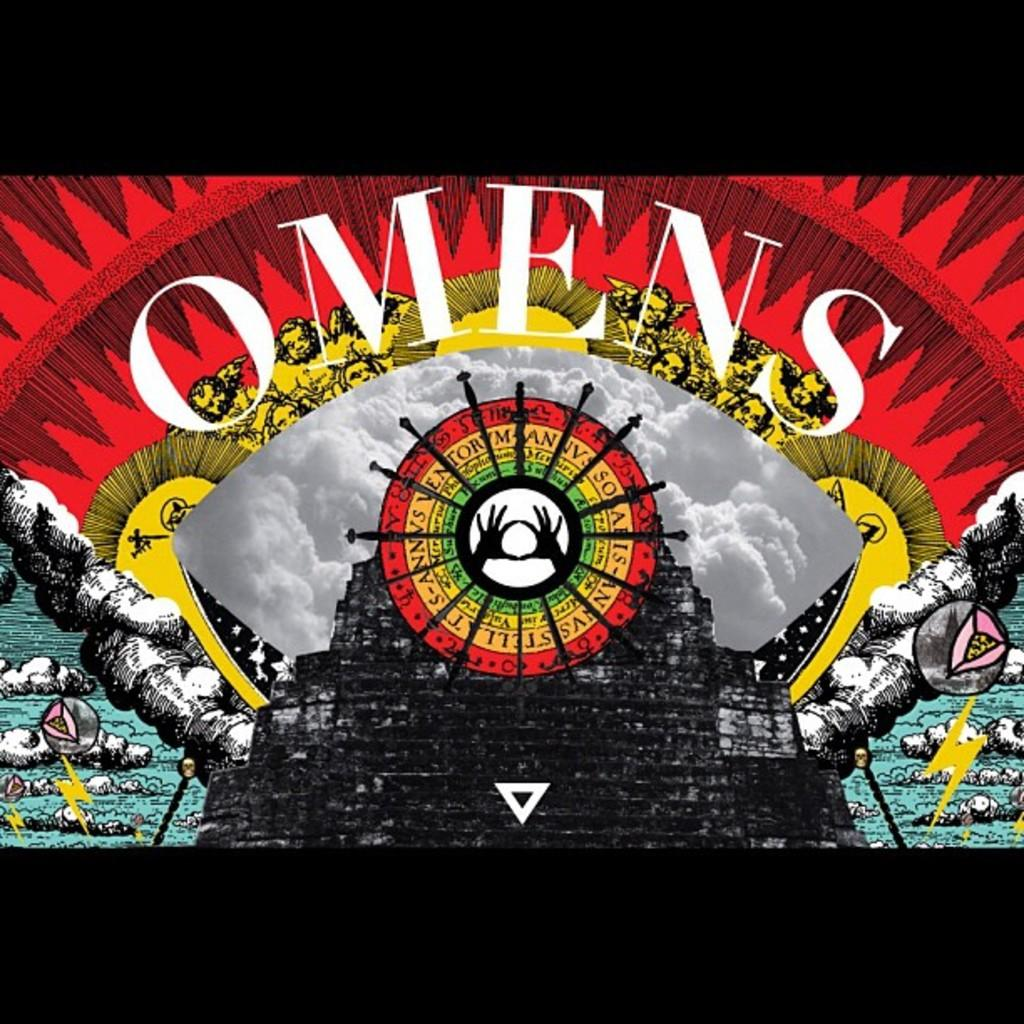<image>
Offer a succinct explanation of the picture presented. the Omens imagehas many colors and shapes of hands in the center 